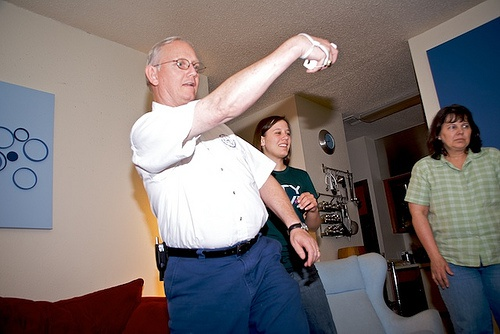Describe the objects in this image and their specific colors. I can see people in gray, white, navy, lightpink, and black tones, people in gray, darkgray, and black tones, couch in gray, black, maroon, and brown tones, people in gray, black, salmon, navy, and brown tones, and chair in gray and black tones in this image. 